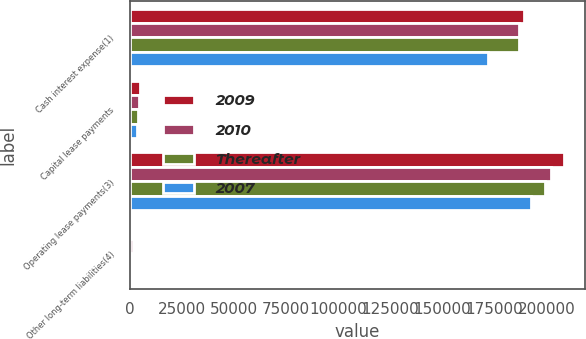<chart> <loc_0><loc_0><loc_500><loc_500><stacked_bar_chart><ecel><fcel>Cash interest expense(1)<fcel>Capital lease payments<fcel>Operating lease payments(3)<fcel>Other long-term liabilities(4)<nl><fcel>2009<fcel>189000<fcel>4965<fcel>208257<fcel>155<nl><fcel>2010<fcel>187000<fcel>4507<fcel>202212<fcel>1852<nl><fcel>Thereafter<fcel>187000<fcel>3880<fcel>199286<fcel>167<nl><fcel>2007<fcel>172000<fcel>3788<fcel>192487<fcel>176<nl></chart> 